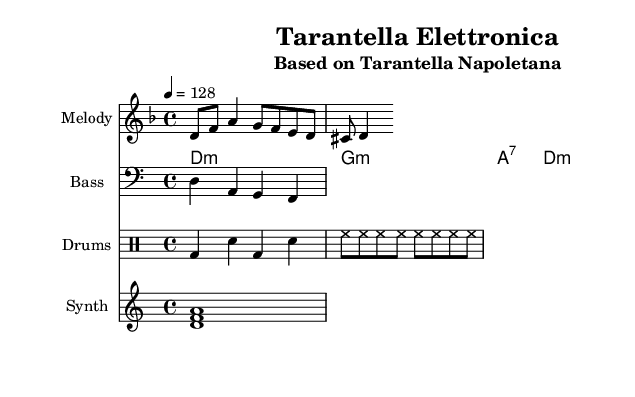What is the key signature of this music? The key signature has two flats (B♭ and E♭), indicating that the music is in D minor, which contains these flats.
Answer: D minor What is the time signature of this piece? The time signature is indicated as 4/4, meaning there are four beats in each measure, and the quarter note gets one beat.
Answer: 4/4 What tempo marking is used in the music? The tempo marking indicates a speed of 128 beats per minute, showing how fast the piece should be played.
Answer: 128 How many measures are in the melody part? Counting each measure from the music, there are four clear measures in the melody section, each containing a segment of notes.
Answer: 4 What type of chords are used in the harmony section? The chords listed are minor and a seventh chord, specifically D minor, G minor, A7, and D minor, which contribute to the harmonic structure characteristic of the piece.
Answer: Minor and seventh chords What percussion instruments are indicated in the score? The percussion part features a bass drum (bd), snare drum (sn), and hi-hat (hh), which are typical elements in house music rhythm sections.
Answer: Bass drum, snare drum, hi-hat What type of electronic instrument is used in this arrangement? The score includes a synth pad, which is typically used in house music to create atmospheric sounds and textures.
Answer: Synth pad 